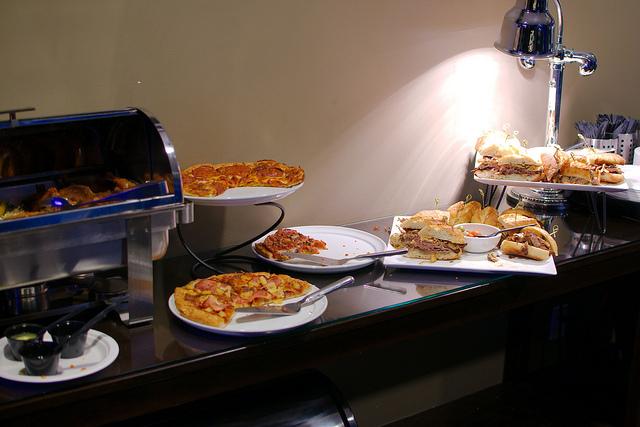Are these sample plates?
Quick response, please. No. According to the picture, does this food look untouched?
Quick response, please. No. Are there heat lamps?
Quick response, please. Yes. Is this a buffet?
Quick response, please. Yes. Has half the pizza been served?
Write a very short answer. Yes. How many plates have food on them?
Give a very brief answer. 5. 